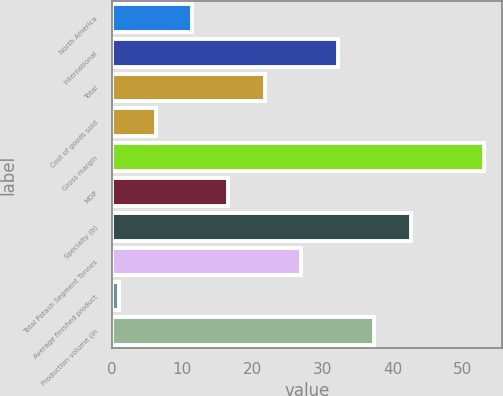<chart> <loc_0><loc_0><loc_500><loc_500><bar_chart><fcel>North America<fcel>International<fcel>Total<fcel>Cost of goods sold<fcel>Gross margin<fcel>MOP<fcel>Specialty (b)<fcel>Total Potash Segment Tonnes<fcel>Average finished product<fcel>Production volume (in<nl><fcel>11.4<fcel>32.2<fcel>21.8<fcel>6.2<fcel>53<fcel>16.6<fcel>42.6<fcel>27<fcel>1<fcel>37.4<nl></chart> 